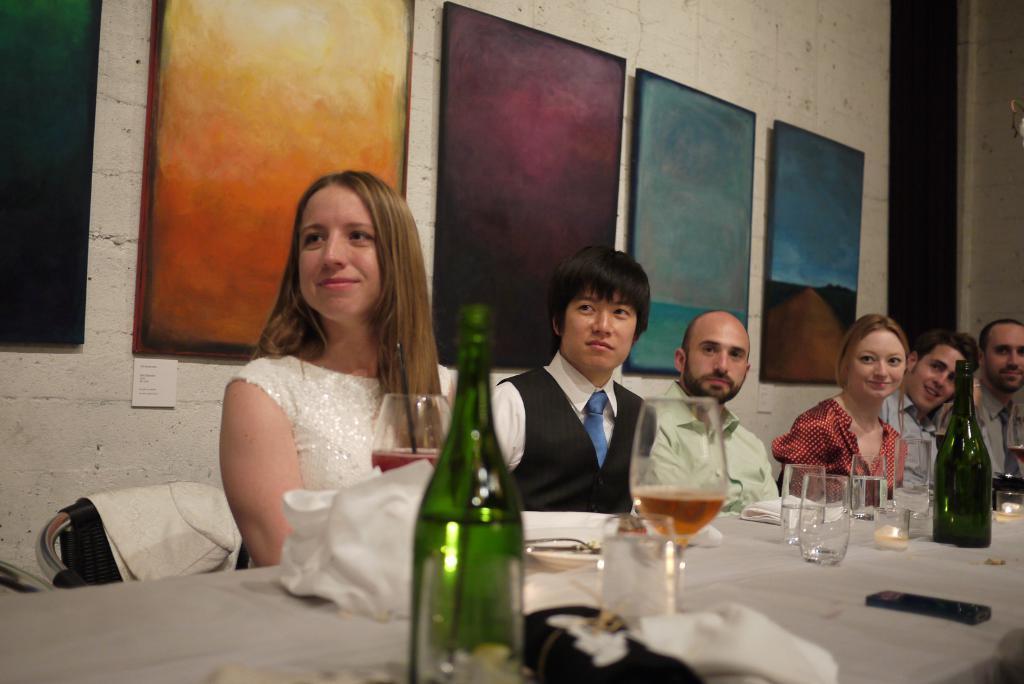How would you summarize this image in a sentence or two? In this image we can see a table. On table bottles, glasses and napkins are present. Behind table people are sitting. Background of the image wall is present, on wall so many frames are attached. 